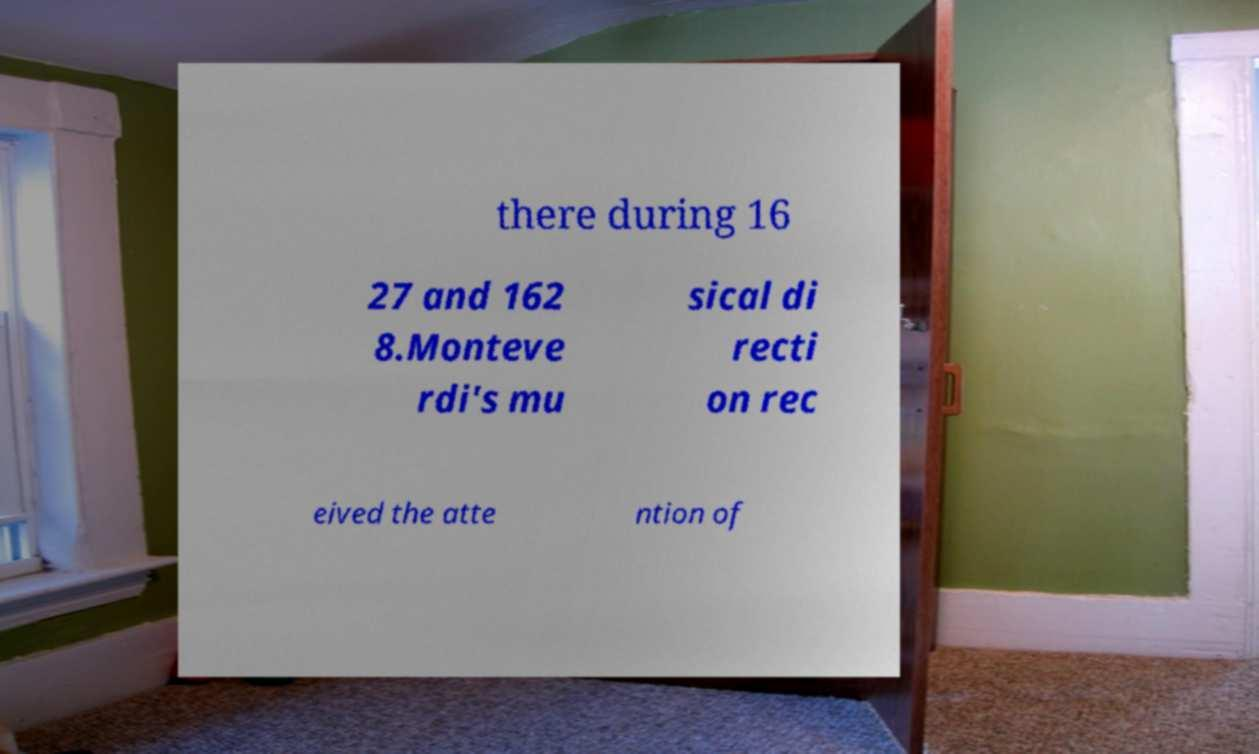Please identify and transcribe the text found in this image. there during 16 27 and 162 8.Monteve rdi's mu sical di recti on rec eived the atte ntion of 